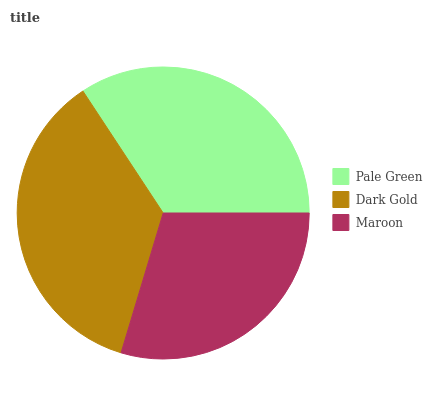Is Maroon the minimum?
Answer yes or no. Yes. Is Dark Gold the maximum?
Answer yes or no. Yes. Is Dark Gold the minimum?
Answer yes or no. No. Is Maroon the maximum?
Answer yes or no. No. Is Dark Gold greater than Maroon?
Answer yes or no. Yes. Is Maroon less than Dark Gold?
Answer yes or no. Yes. Is Maroon greater than Dark Gold?
Answer yes or no. No. Is Dark Gold less than Maroon?
Answer yes or no. No. Is Pale Green the high median?
Answer yes or no. Yes. Is Pale Green the low median?
Answer yes or no. Yes. Is Maroon the high median?
Answer yes or no. No. Is Maroon the low median?
Answer yes or no. No. 